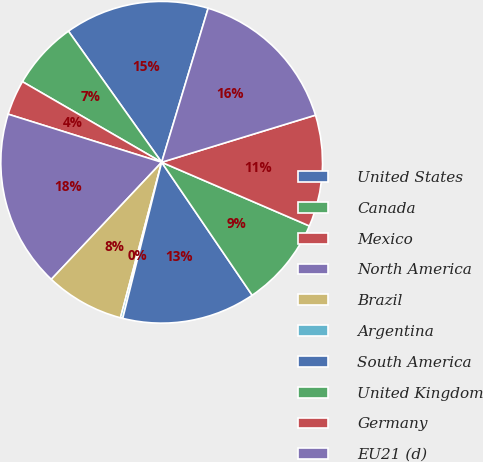Convert chart. <chart><loc_0><loc_0><loc_500><loc_500><pie_chart><fcel>United States<fcel>Canada<fcel>Mexico<fcel>North America<fcel>Brazil<fcel>Argentina<fcel>South America<fcel>United Kingdom<fcel>Germany<fcel>EU21 (d)<nl><fcel>14.5%<fcel>6.81%<fcel>3.52%<fcel>17.8%<fcel>7.91%<fcel>0.23%<fcel>13.4%<fcel>9.01%<fcel>11.21%<fcel>15.6%<nl></chart> 